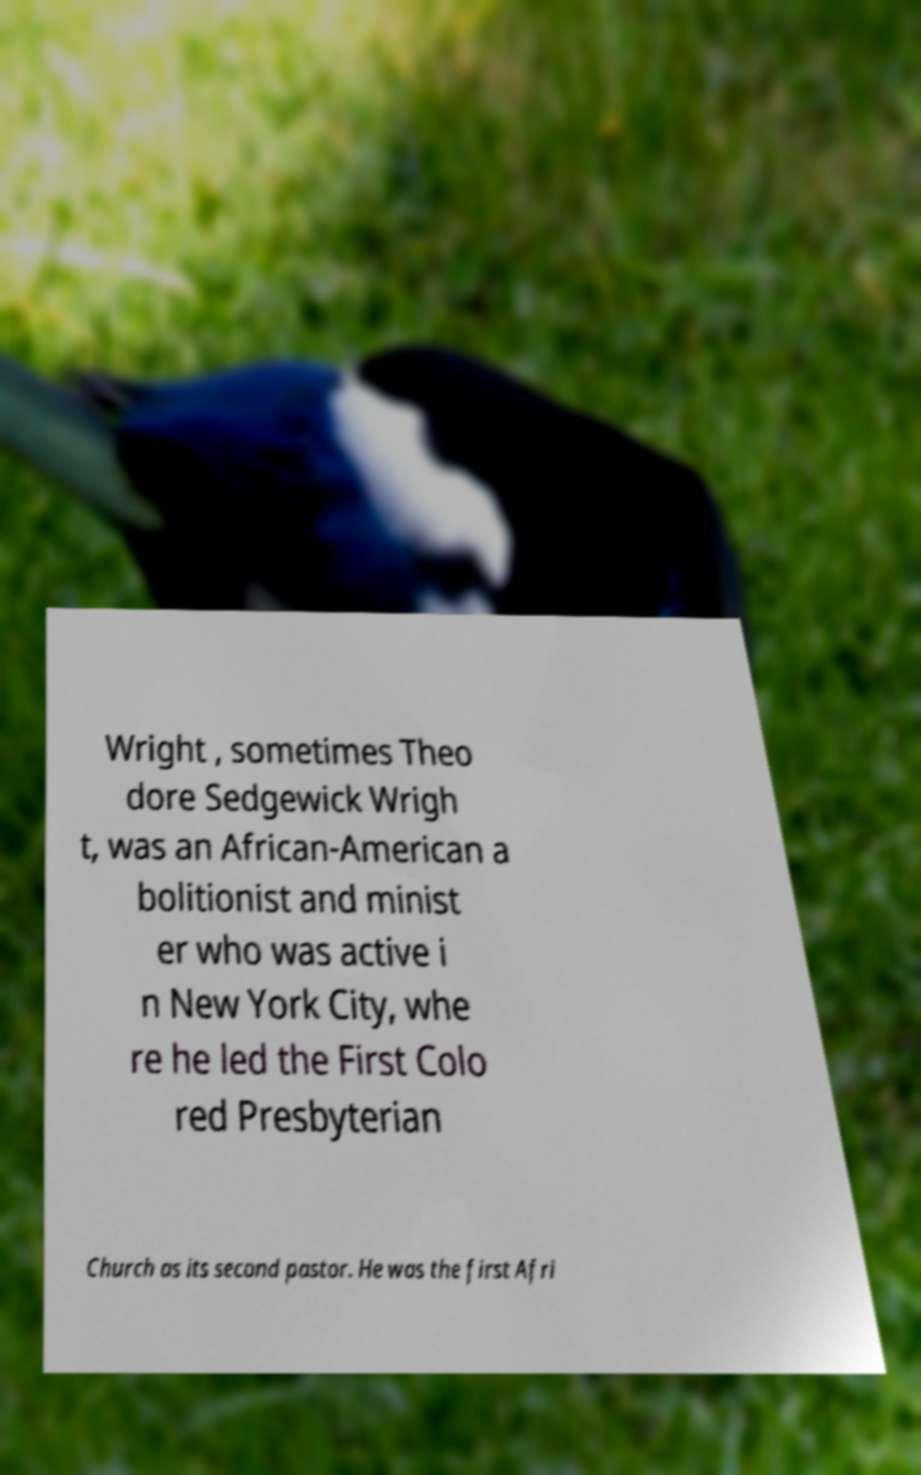There's text embedded in this image that I need extracted. Can you transcribe it verbatim? Wright , sometimes Theo dore Sedgewick Wrigh t, was an African-American a bolitionist and minist er who was active i n New York City, whe re he led the First Colo red Presbyterian Church as its second pastor. He was the first Afri 